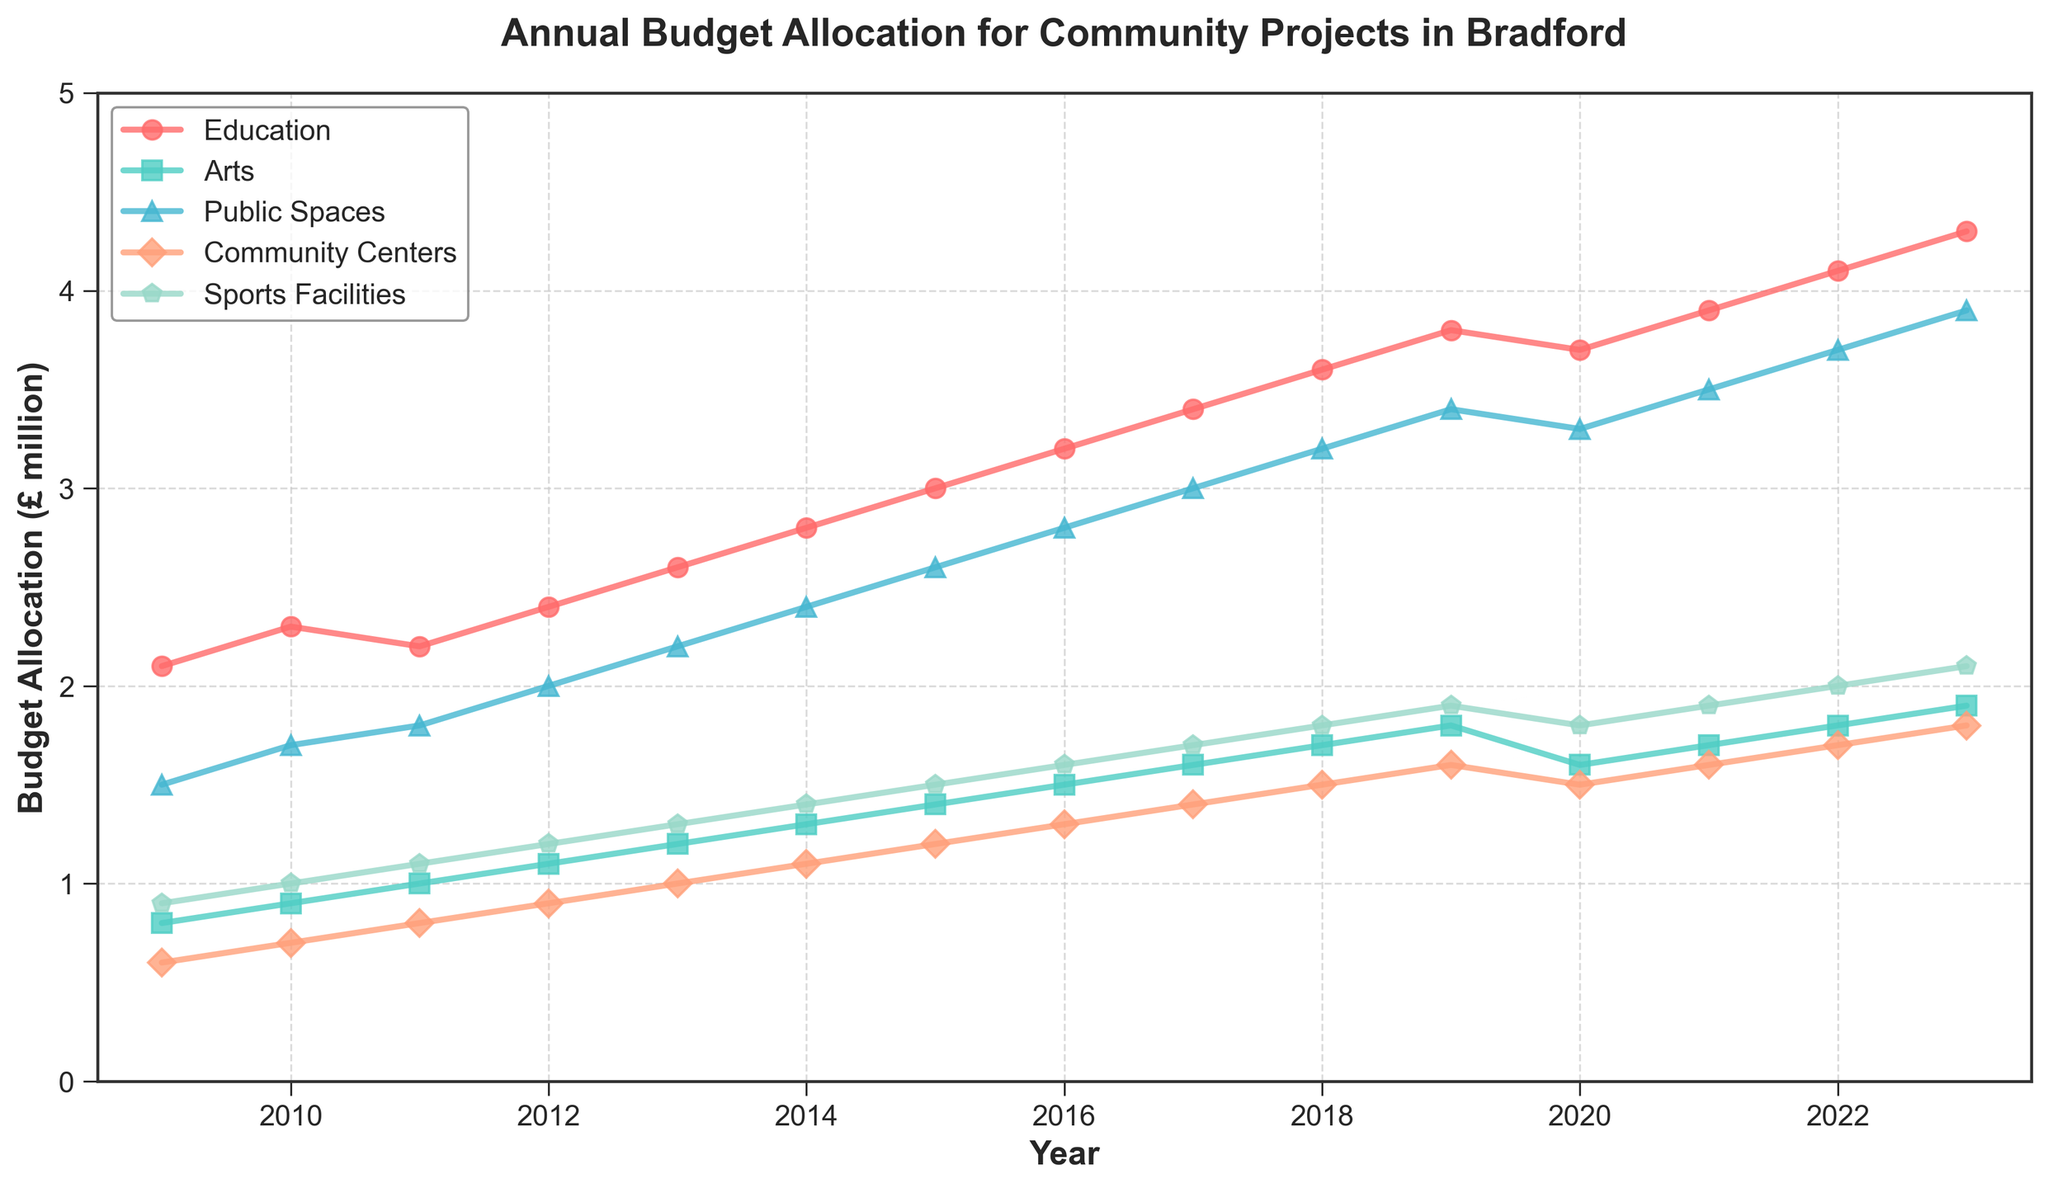What is the budget allocation for Education in 2013? Locate the marker for the Education line at the year 2013. Read the y-axis value corresponding to this marker.
Answer: 2.6 million pounds Between 2012 and 2023, which category experienced the highest increase in budget allocation? Calculate the difference in budget allocation between 2012 and 2023 for each category: Education (4.3 - 2.4 = 1.9), Arts (1.9 - 1.1 = 0.8), Public Spaces (3.9 - 2.0 = 1.9), Community Centers (1.8 - 0.9 = 0.9), Sports Facilities (2.1 - 1.2 = 0.9). Compare the differences to find the highest increase.
Answer: Education and Public Spaces In which year did the Community Centers budget surpass 1.5 million pounds for the first time? Follow the Community Centers line and identify the first year it passes the 1.5 million pound mark on the y-axis.
Answer: 2018 What was the total budget allocation for all categories in 2021? Add the budget allocations for all categories in the year 2021: Education (3.9) + Arts (1.7) + Public Spaces (3.5) + Community Centers (1.6) + Sports Facilities (1.9).
Answer: 12.6 million pounds Did the budget for Sports Facilities ever decrease during the 15-year period, and if so, between which years? Check the Sports Facilities line for any dips. Identify the years before and after the decrease.
Answer: Yes, between 2019 and 2020 Which category consistently saw an increase in its budget every year? Examine each line and check if there's a consistent upward trend without any dips.
Answer: Education What was the average annual budget allocation for Arts from 2009 to 2023? Sum the annual budget allocations for Arts (0.8 + 0.9 + 1.0 + 1.1 + 1.2 + 1.3 + 1.4 + 1.5 + 1.6 + 1.7 + 1.8 + 1.6 + 1.7 + 1.8 + 1.9) and divide by the number of years (15).
Answer: 1.39 million pounds Compare the budget allocation between Education and Public Spaces in 2020. Which category received more funding and by how much? Locate the markers for Education (3.7 million pounds) and Public Spaces (3.3 million pounds) in 2020. Subtract the lesser value from the greater value (3.7 - 3.3).
Answer: Education by 0.4 million pounds Which category had the largest budget allocation in 2023? Identify the highest marker on the y-axis for the year 2023.
Answer: Education 